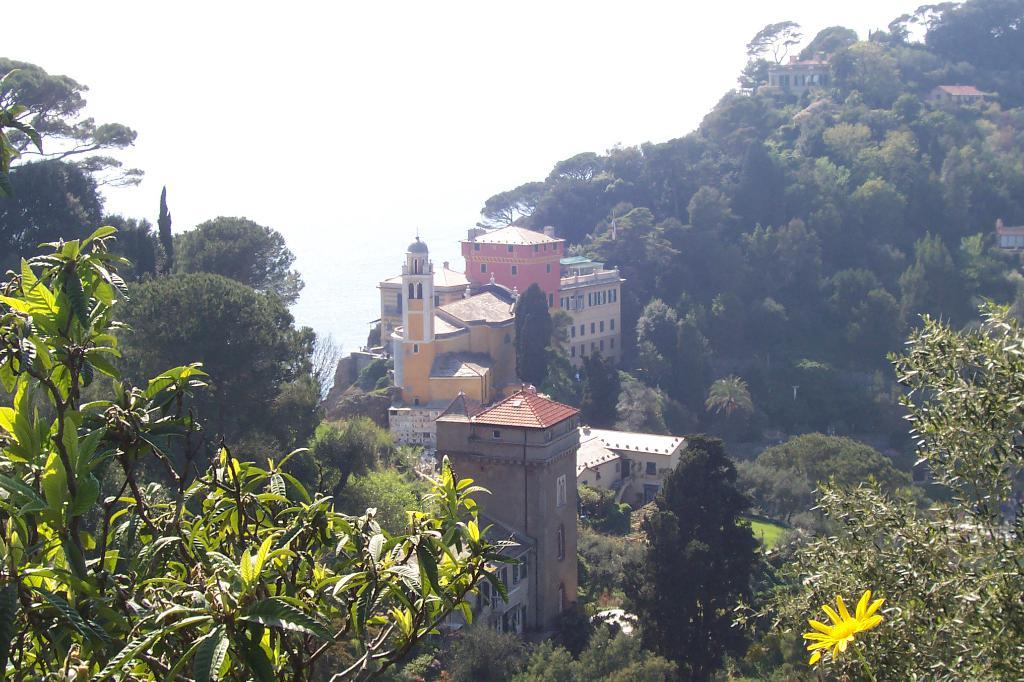What type of natural elements can be seen in the image? There are trees in the image. What type of man-made structures are present in the image? There are buildings in the image. Can you describe any specific flora in the image? There is a yellow color flower in the image. What type of hair can be seen on the company's logo in the image? There is no company or logo present in the image, so it is not possible to determine what type of hair might be on a logo. 